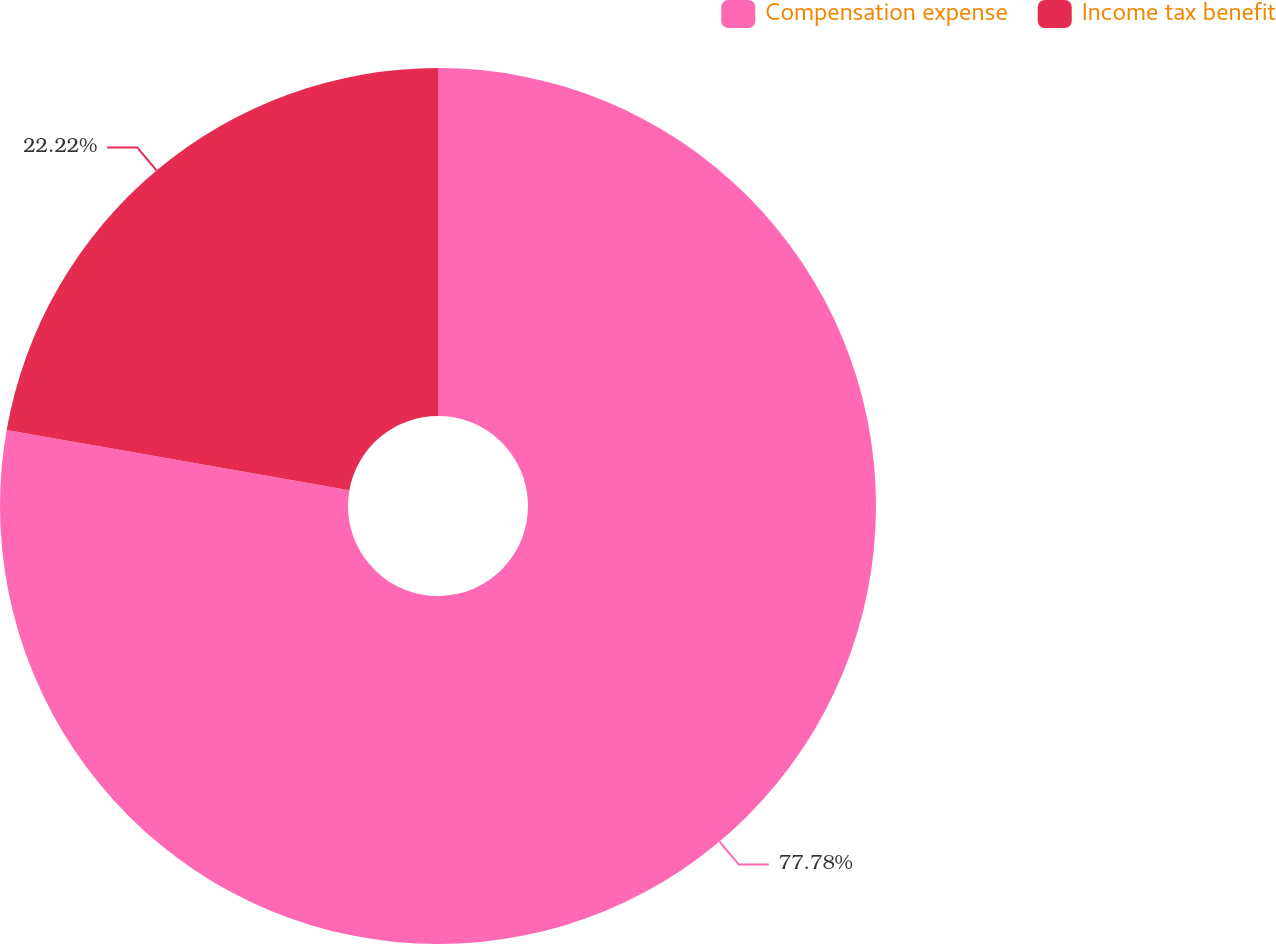Convert chart to OTSL. <chart><loc_0><loc_0><loc_500><loc_500><pie_chart><fcel>Compensation expense<fcel>Income tax benefit<nl><fcel>77.78%<fcel>22.22%<nl></chart> 